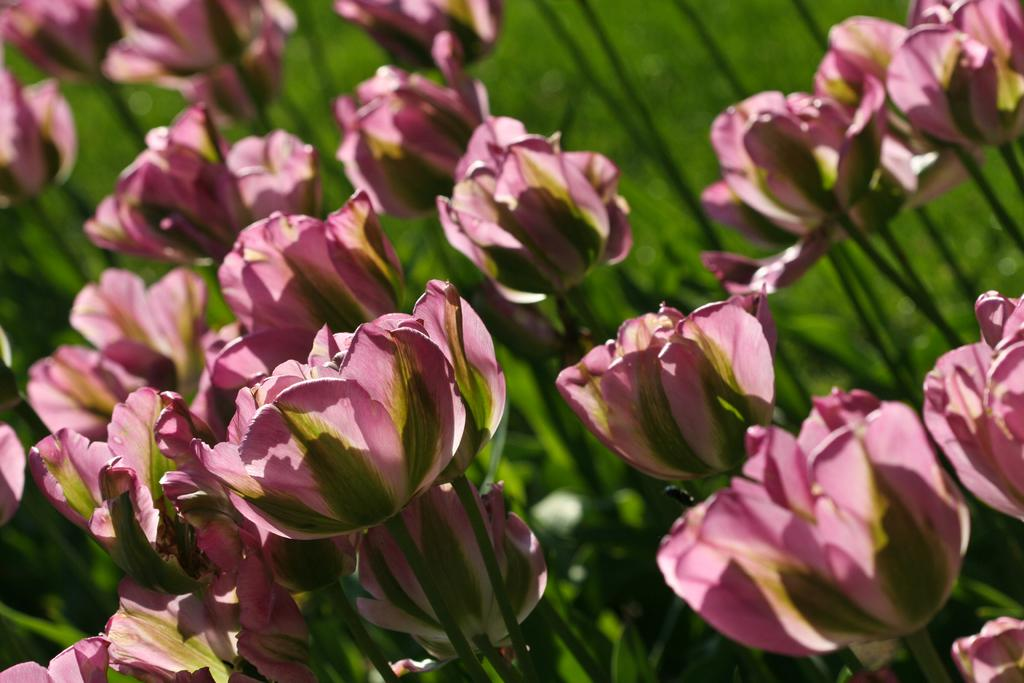What type of living organisms can be seen in the image? Plants can be seen in the image. What color are the flowers on the plants? The flowers on the plants are pink in color. What is the color of the background in the image? The background of the image is green in color. What type of potato is being harvested by the carpenter in the image? There is no potato or carpenter present in the image; it features plants with pink flowers against a green background. 